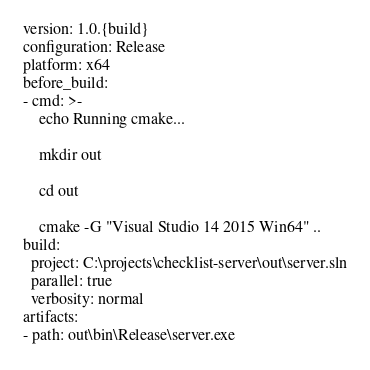Convert code to text. <code><loc_0><loc_0><loc_500><loc_500><_YAML_>version: 1.0.{build}
configuration: Release
platform: x64
before_build:
- cmd: >-
    echo Running cmake...

    mkdir out

    cd out

    cmake -G "Visual Studio 14 2015 Win64" ..
build:
  project: C:\projects\checklist-server\out\server.sln
  parallel: true
  verbosity: normal
artifacts:
- path: out\bin\Release\server.exe</code> 